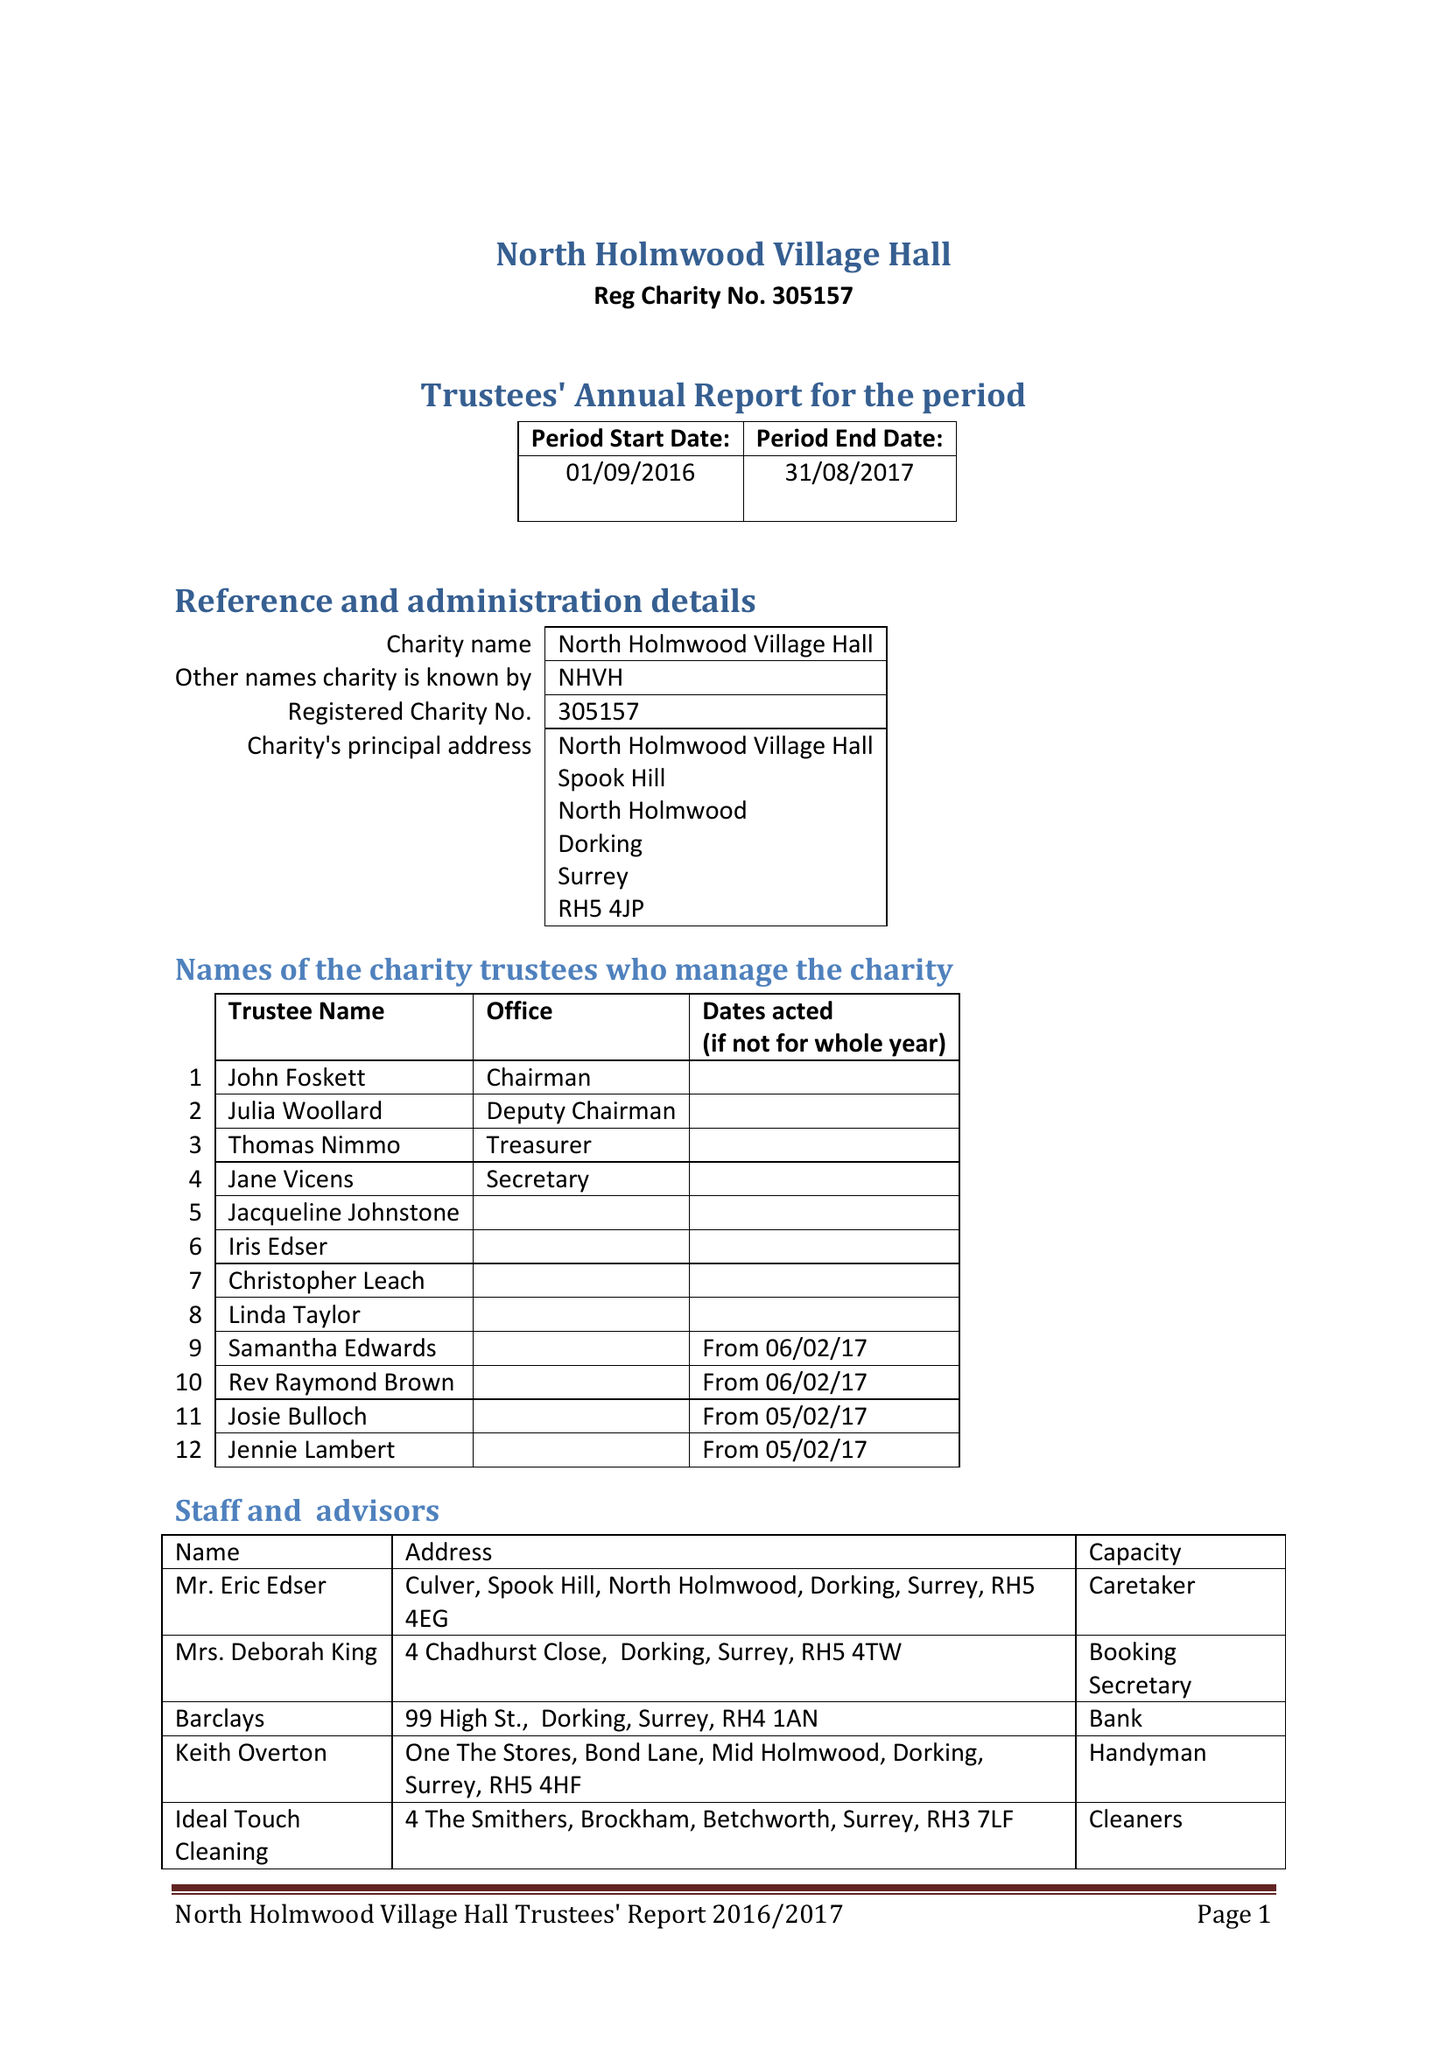What is the value for the address__postcode?
Answer the question using a single word or phrase. RH5 4EG 